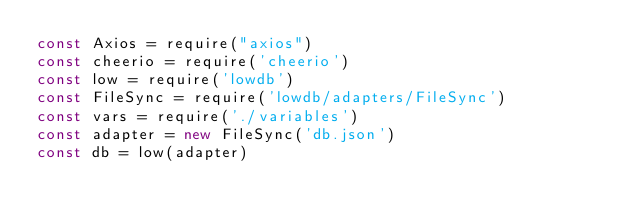<code> <loc_0><loc_0><loc_500><loc_500><_JavaScript_>const Axios = require("axios")
const cheerio = require('cheerio')
const low = require('lowdb')
const FileSync = require('lowdb/adapters/FileSync')
const vars = require('./variables')
const adapter = new FileSync('db.json')
const db = low(adapter)
</code> 